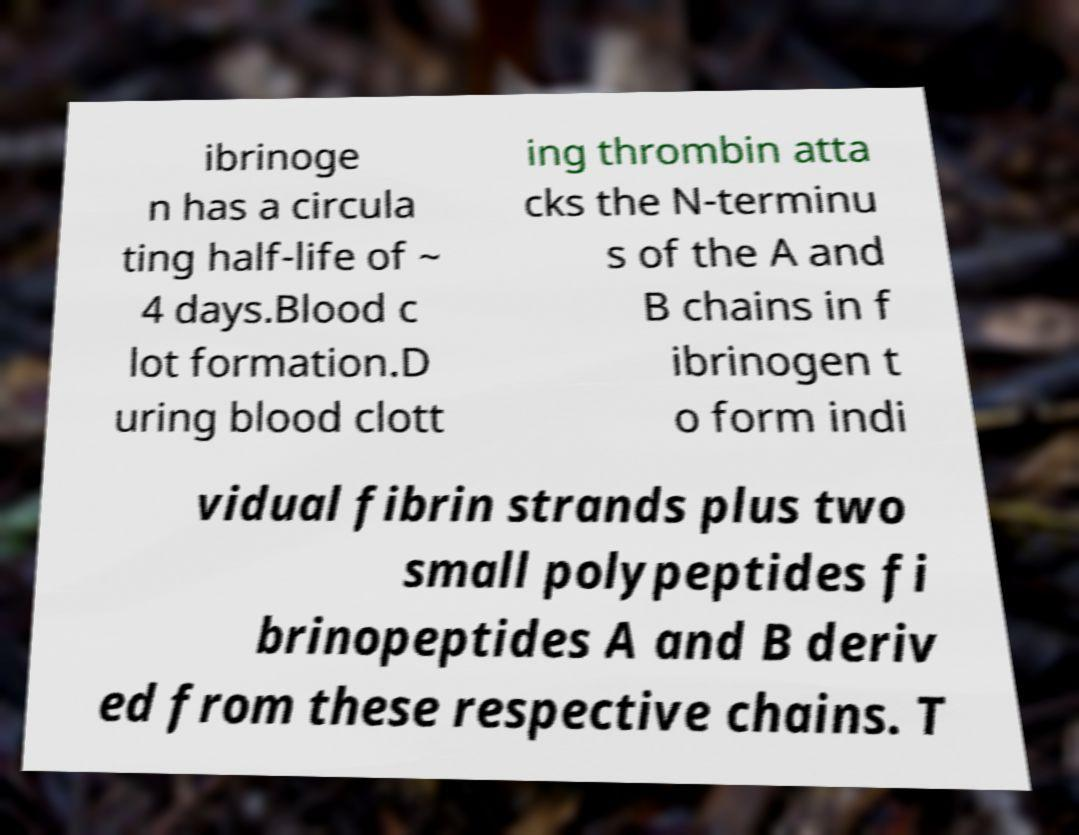For documentation purposes, I need the text within this image transcribed. Could you provide that? ibrinoge n has a circula ting half-life of ~ 4 days.Blood c lot formation.D uring blood clott ing thrombin atta cks the N-terminu s of the A and B chains in f ibrinogen t o form indi vidual fibrin strands plus two small polypeptides fi brinopeptides A and B deriv ed from these respective chains. T 